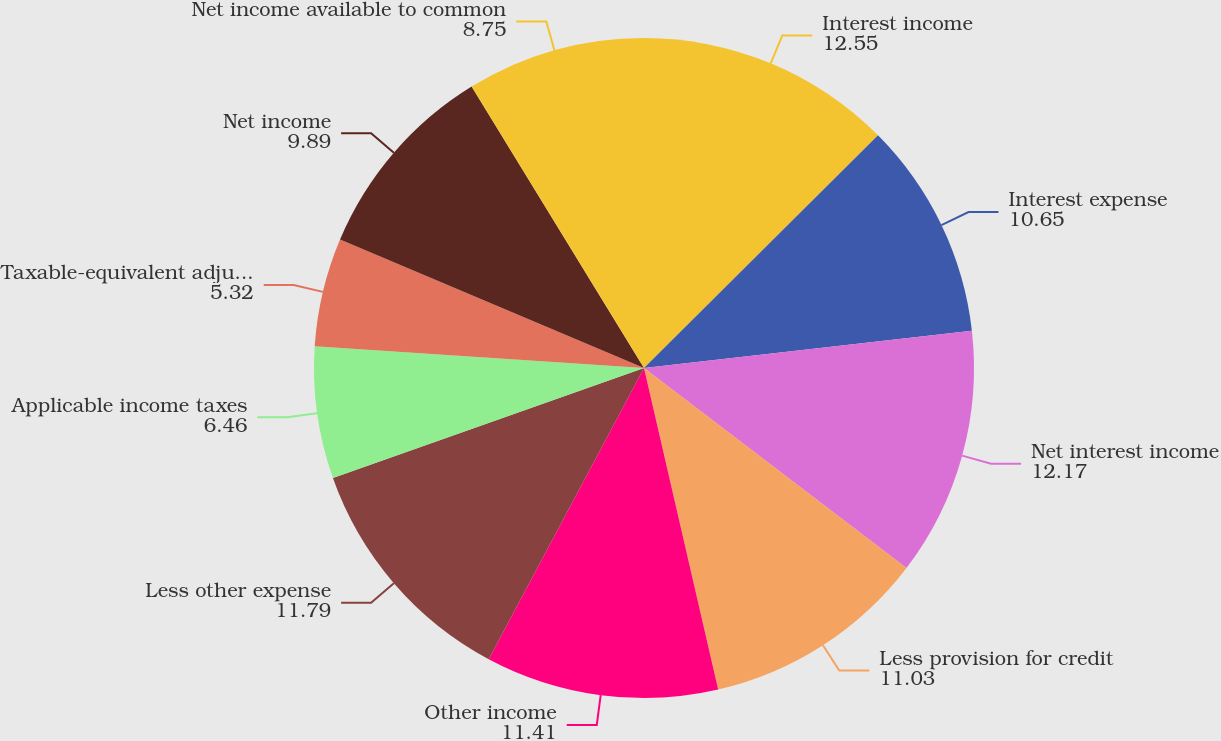<chart> <loc_0><loc_0><loc_500><loc_500><pie_chart><fcel>Interest income<fcel>Interest expense<fcel>Net interest income<fcel>Less provision for credit<fcel>Other income<fcel>Less other expense<fcel>Applicable income taxes<fcel>Taxable-equivalent adjustment<fcel>Net income<fcel>Net income available to common<nl><fcel>12.55%<fcel>10.65%<fcel>12.17%<fcel>11.03%<fcel>11.41%<fcel>11.79%<fcel>6.46%<fcel>5.32%<fcel>9.89%<fcel>8.75%<nl></chart> 